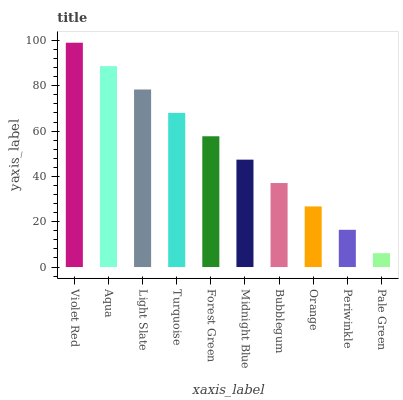Is Aqua the minimum?
Answer yes or no. No. Is Aqua the maximum?
Answer yes or no. No. Is Violet Red greater than Aqua?
Answer yes or no. Yes. Is Aqua less than Violet Red?
Answer yes or no. Yes. Is Aqua greater than Violet Red?
Answer yes or no. No. Is Violet Red less than Aqua?
Answer yes or no. No. Is Forest Green the high median?
Answer yes or no. Yes. Is Midnight Blue the low median?
Answer yes or no. Yes. Is Midnight Blue the high median?
Answer yes or no. No. Is Aqua the low median?
Answer yes or no. No. 